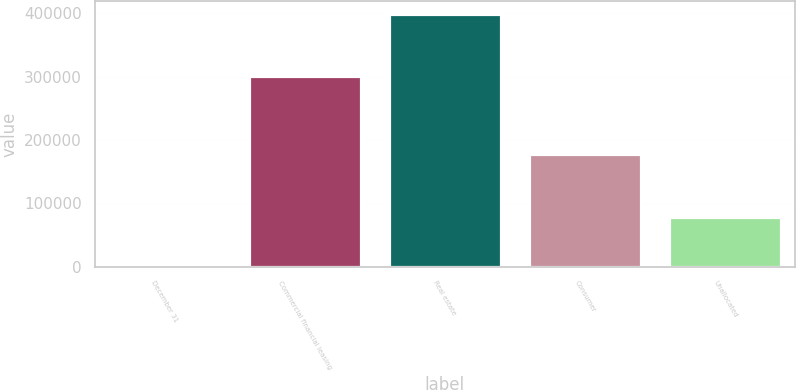<chart> <loc_0><loc_0><loc_500><loc_500><bar_chart><fcel>December 31<fcel>Commercial financial leasing<fcel>Real estate<fcel>Consumer<fcel>Unallocated<nl><fcel>2015<fcel>300404<fcel>399069<fcel>178320<fcel>78199<nl></chart> 